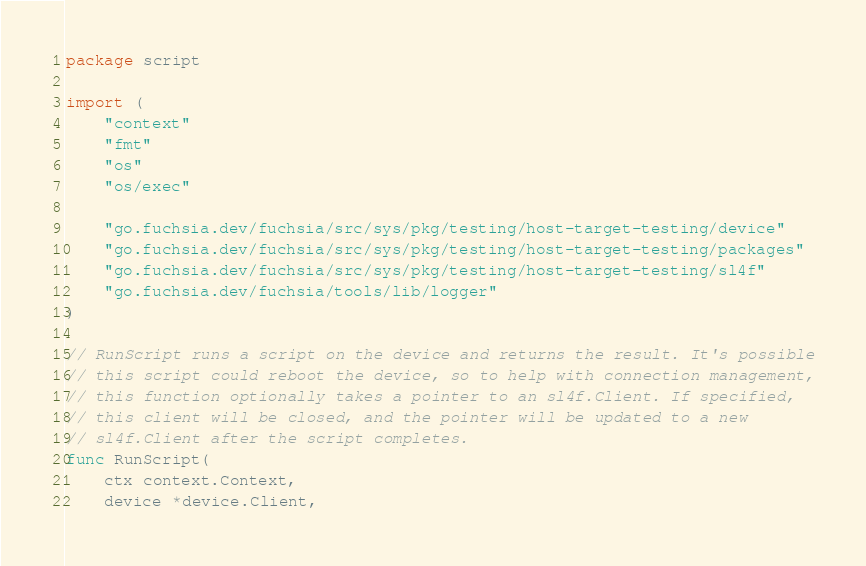Convert code to text. <code><loc_0><loc_0><loc_500><loc_500><_Go_>
package script

import (
	"context"
	"fmt"
	"os"
	"os/exec"

	"go.fuchsia.dev/fuchsia/src/sys/pkg/testing/host-target-testing/device"
	"go.fuchsia.dev/fuchsia/src/sys/pkg/testing/host-target-testing/packages"
	"go.fuchsia.dev/fuchsia/src/sys/pkg/testing/host-target-testing/sl4f"
	"go.fuchsia.dev/fuchsia/tools/lib/logger"
)

// RunScript runs a script on the device and returns the result. It's possible
// this script could reboot the device, so to help with connection management,
// this function optionally takes a pointer to an sl4f.Client. If specified,
// this client will be closed, and the pointer will be updated to a new
// sl4f.Client after the script completes.
func RunScript(
	ctx context.Context,
	device *device.Client,</code> 